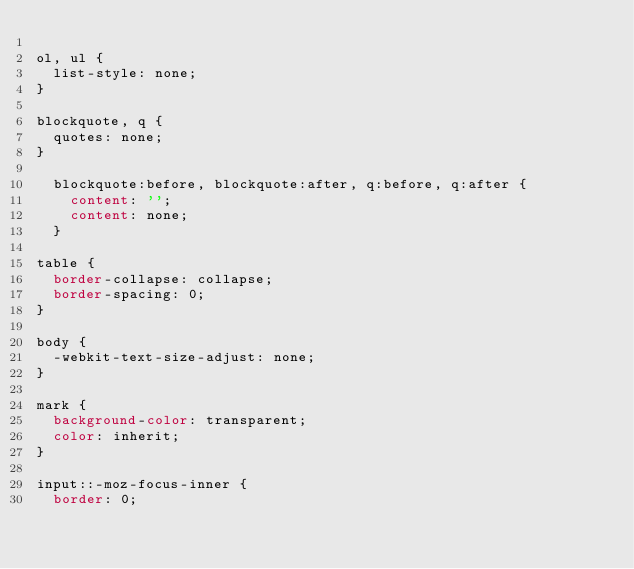<code> <loc_0><loc_0><loc_500><loc_500><_CSS_>
ol, ul {
	list-style: none;
}

blockquote, q {
	quotes: none;
}

	blockquote:before, blockquote:after, q:before, q:after {
		content: '';
		content: none;
	}

table {
	border-collapse: collapse;
	border-spacing: 0;
}

body {
	-webkit-text-size-adjust: none;
}

mark {
	background-color: transparent;
	color: inherit;
}

input::-moz-focus-inner {
	border: 0;</code> 